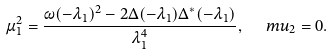Convert formula to latex. <formula><loc_0><loc_0><loc_500><loc_500>\mu _ { 1 } ^ { 2 } = \frac { \omega ( - \lambda _ { 1 } ) ^ { 2 } - 2 \Delta ( - \lambda _ { 1 } ) \Delta ^ { * } ( - \lambda _ { 1 } ) } { \lambda _ { 1 } ^ { 4 } } , \ \ \ m u _ { 2 } = 0 .</formula> 